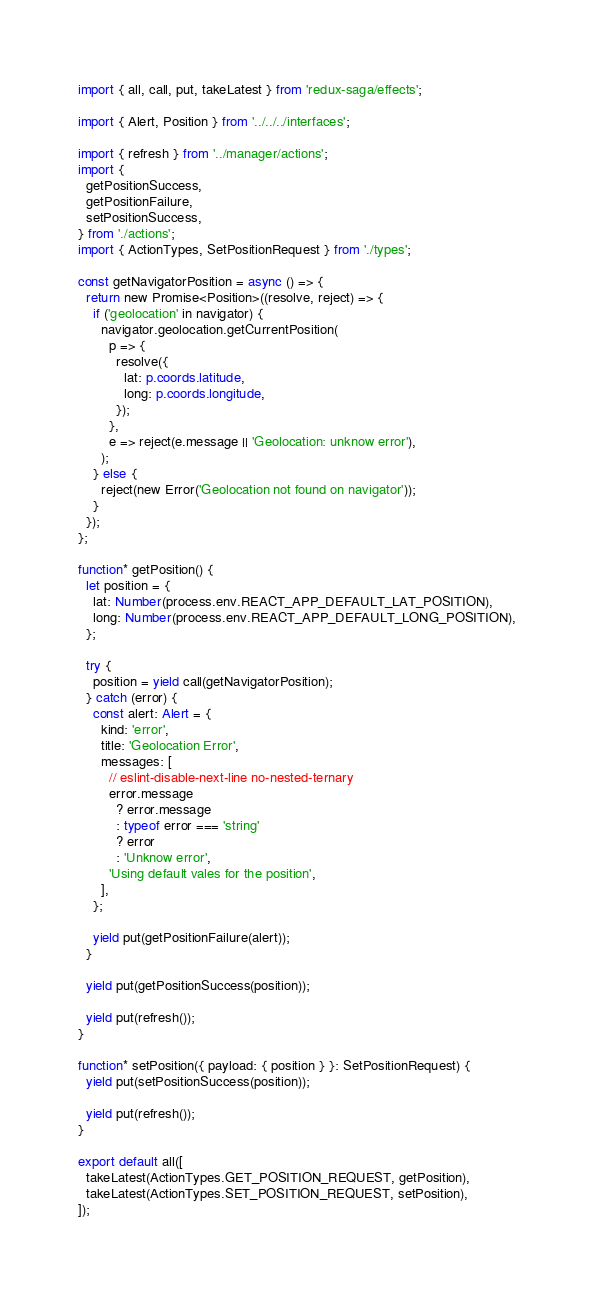Convert code to text. <code><loc_0><loc_0><loc_500><loc_500><_TypeScript_>import { all, call, put, takeLatest } from 'redux-saga/effects';

import { Alert, Position } from '../../../interfaces';

import { refresh } from '../manager/actions';
import {
  getPositionSuccess,
  getPositionFailure,
  setPositionSuccess,
} from './actions';
import { ActionTypes, SetPositionRequest } from './types';

const getNavigatorPosition = async () => {
  return new Promise<Position>((resolve, reject) => {
    if ('geolocation' in navigator) {
      navigator.geolocation.getCurrentPosition(
        p => {
          resolve({
            lat: p.coords.latitude,
            long: p.coords.longitude,
          });
        },
        e => reject(e.message || 'Geolocation: unknow error'),
      );
    } else {
      reject(new Error('Geolocation not found on navigator'));
    }
  });
};

function* getPosition() {
  let position = {
    lat: Number(process.env.REACT_APP_DEFAULT_LAT_POSITION),
    long: Number(process.env.REACT_APP_DEFAULT_LONG_POSITION),
  };

  try {
    position = yield call(getNavigatorPosition);
  } catch (error) {
    const alert: Alert = {
      kind: 'error',
      title: 'Geolocation Error',
      messages: [
        // eslint-disable-next-line no-nested-ternary
        error.message
          ? error.message
          : typeof error === 'string'
          ? error
          : 'Unknow error',
        'Using default vales for the position',
      ],
    };

    yield put(getPositionFailure(alert));
  }

  yield put(getPositionSuccess(position));

  yield put(refresh());
}

function* setPosition({ payload: { position } }: SetPositionRequest) {
  yield put(setPositionSuccess(position));

  yield put(refresh());
}

export default all([
  takeLatest(ActionTypes.GET_POSITION_REQUEST, getPosition),
  takeLatest(ActionTypes.SET_POSITION_REQUEST, setPosition),
]);
</code> 